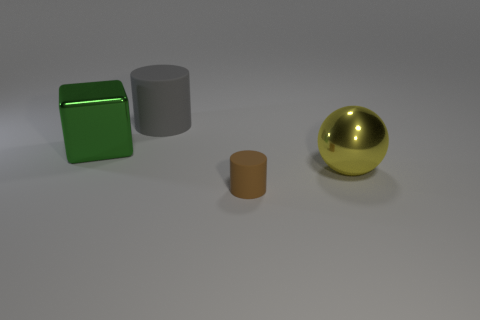Is the number of cylinders that are on the left side of the green object greater than the number of big shiny things that are behind the big yellow metallic thing?
Offer a terse response. No. There is a cylinder that is behind the yellow thing; what material is it?
Ensure brevity in your answer.  Rubber. There is a yellow object; does it have the same shape as the matte thing that is to the right of the big gray cylinder?
Your answer should be very brief. No. How many cylinders are right of the rubber cylinder that is in front of the cylinder behind the large metal ball?
Make the answer very short. 0. The other rubber object that is the same shape as the gray object is what color?
Your response must be concise. Brown. Is there any other thing that is the same shape as the brown object?
Your answer should be compact. Yes. How many balls are green rubber objects or matte objects?
Your answer should be very brief. 0. What is the shape of the big gray matte object?
Keep it short and to the point. Cylinder. There is a large gray cylinder; are there any big cubes behind it?
Keep it short and to the point. No. Are the green cube and the object that is in front of the large yellow ball made of the same material?
Give a very brief answer. No. 